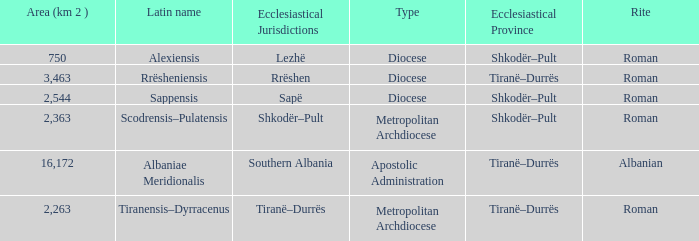What Area (km 2) is lowest with a type being Apostolic Administration? 16172.0. 